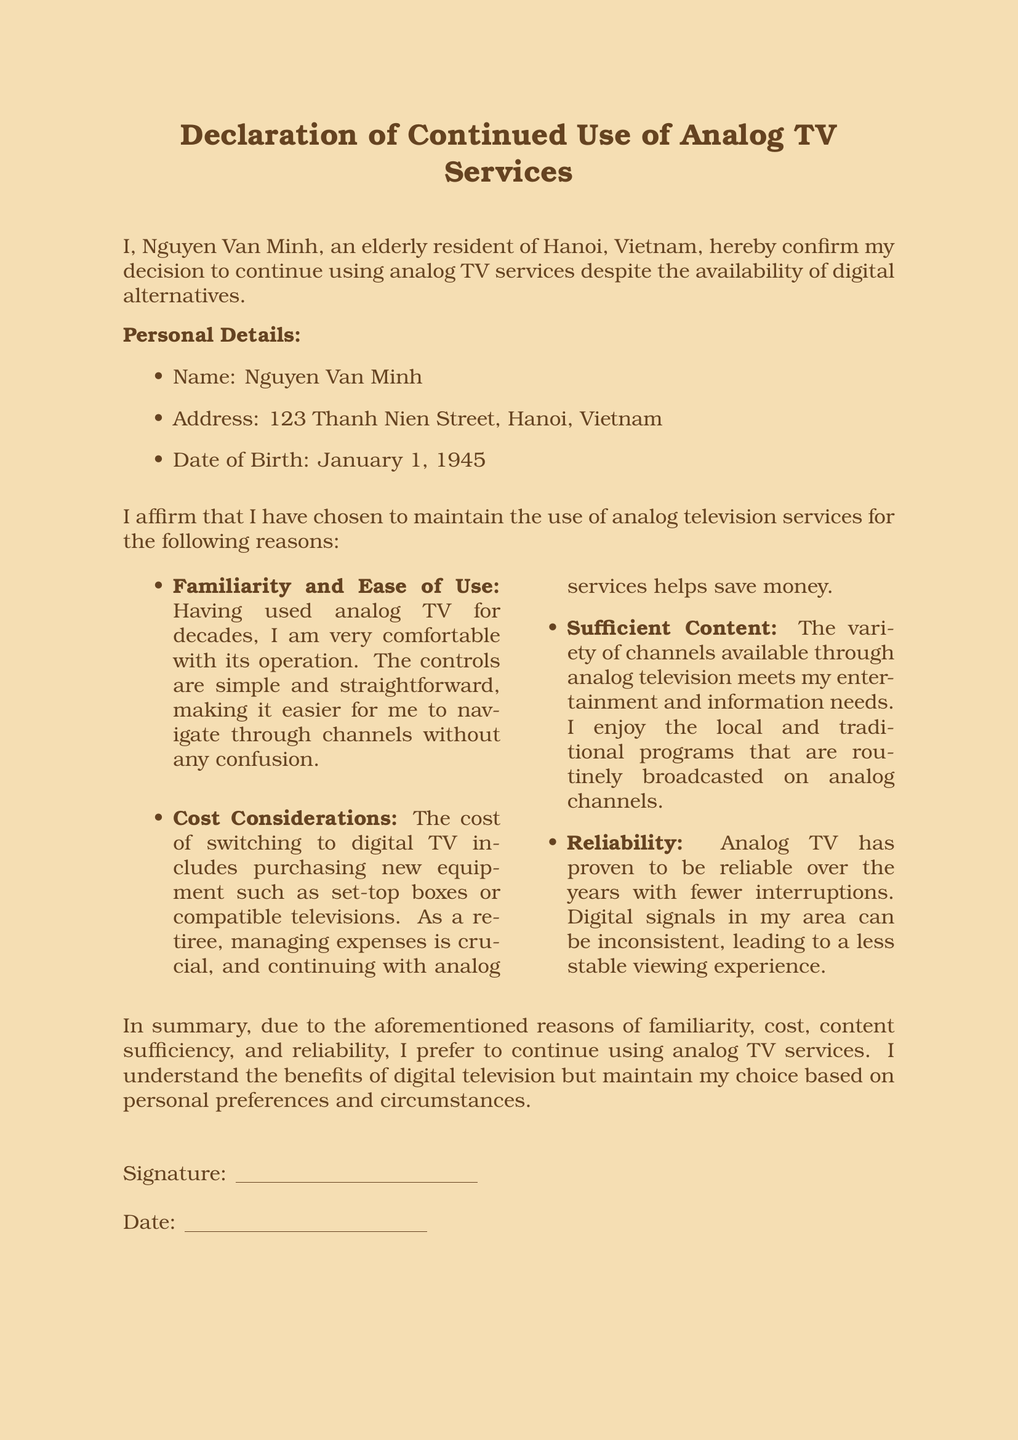What is the name of the person making the declaration? The name of the person making the declaration is explicitly stated in the document.
Answer: Nguyen Van Minh What is the address listed in the declaration? The address in the declaration provides the location of the individual making the declaration.
Answer: 123 Thanh Nien Street, Hanoi, Vietnam What is the date of birth of the declarant? The date of birth is provided in the personal details section to confirm the identity of the person.
Answer: January 1, 1945 What is one reason for continuing to use analog TV mentioned in the document? The document lists several reasons for the choice to remain with analog TV, indicating personal preferences and limitations.
Answer: Familiarity and Ease of Use What is the primary concern related to costs for the declarant? The declaration highlights financial considerations as a significant reason for continuing with analog TV services.
Answer: Cost Considerations How does the declarant feel about the content available through analog TV? The document reflects the declarant's satisfaction with the available programming as part of their reasoning.
Answer: Sufficient Content What is mentioned as a drawback of digital TV in the document? The declaration compares the reliability of analog and digital TV, indicating issues faced with the latter.
Answer: Inconsistent signals What type of services is the declarant opting to continue? The document's title and content clarify the specific services the declarant wishes to retain.
Answer: Analog TV services When was the declaration signed? The declaration requires the date to be filled in for processing and validation purposes.
Answer: (to be filled) 